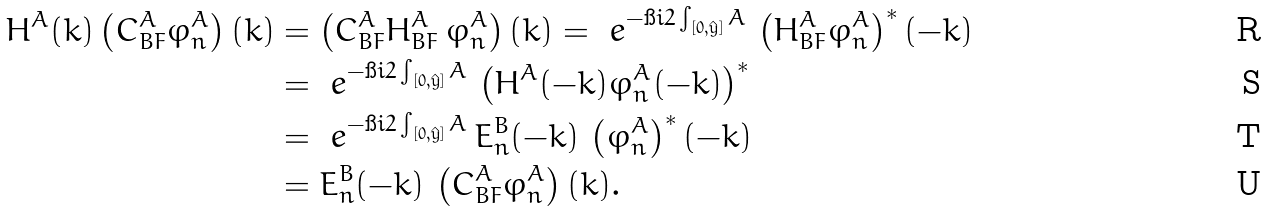Convert formula to latex. <formula><loc_0><loc_0><loc_500><loc_500>H ^ { A } ( k ) \left ( C ^ { A } _ { B F } \varphi _ { n } ^ { A } \right ) ( k ) & = \left ( C ^ { A } _ { B F } H ^ { A } _ { B F } \, \varphi _ { n } ^ { A } \right ) ( k ) = \ e ^ { - \i i 2 \int _ { [ 0 , \hat { y } ] } A } \, \left ( H ^ { A } _ { B F } \varphi _ { n } ^ { A } \right ) ^ { \ast } ( - k ) \\ & = \ e ^ { - \i i 2 \int _ { [ 0 , \hat { y } ] } A } \, \left ( H ^ { A } ( - k ) \varphi _ { n } ^ { A } ( - k ) \right ) ^ { \ast } \\ & = \ e ^ { - \i i 2 \int _ { [ 0 , \hat { y } ] } A } \, E _ { n } ^ { B } ( - k ) \, \left ( \varphi _ { n } ^ { A } \right ) ^ { \ast } ( - k ) \\ & = E _ { n } ^ { B } ( - k ) \, \left ( C ^ { A } _ { B F } \varphi _ { n } ^ { A } \right ) ( k ) .</formula> 